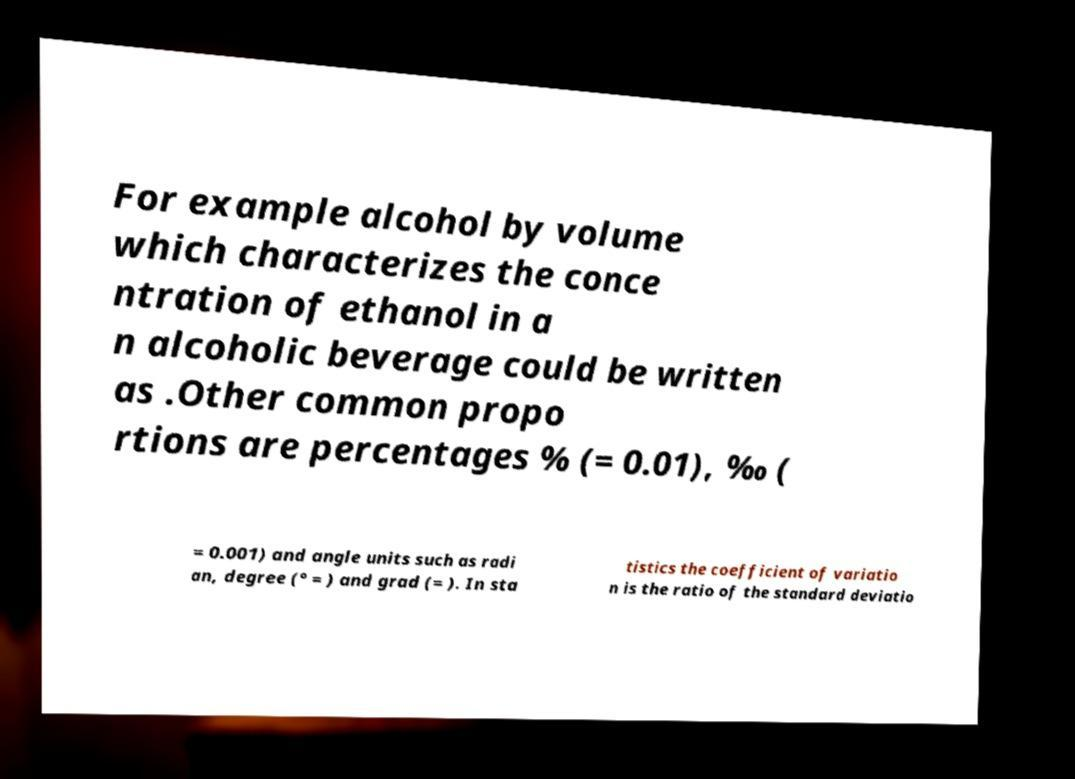For documentation purposes, I need the text within this image transcribed. Could you provide that? For example alcohol by volume which characterizes the conce ntration of ethanol in a n alcoholic beverage could be written as .Other common propo rtions are percentages % (= 0.01), ‰ ( = 0.001) and angle units such as radi an, degree (° = ) and grad (= ). In sta tistics the coefficient of variatio n is the ratio of the standard deviatio 